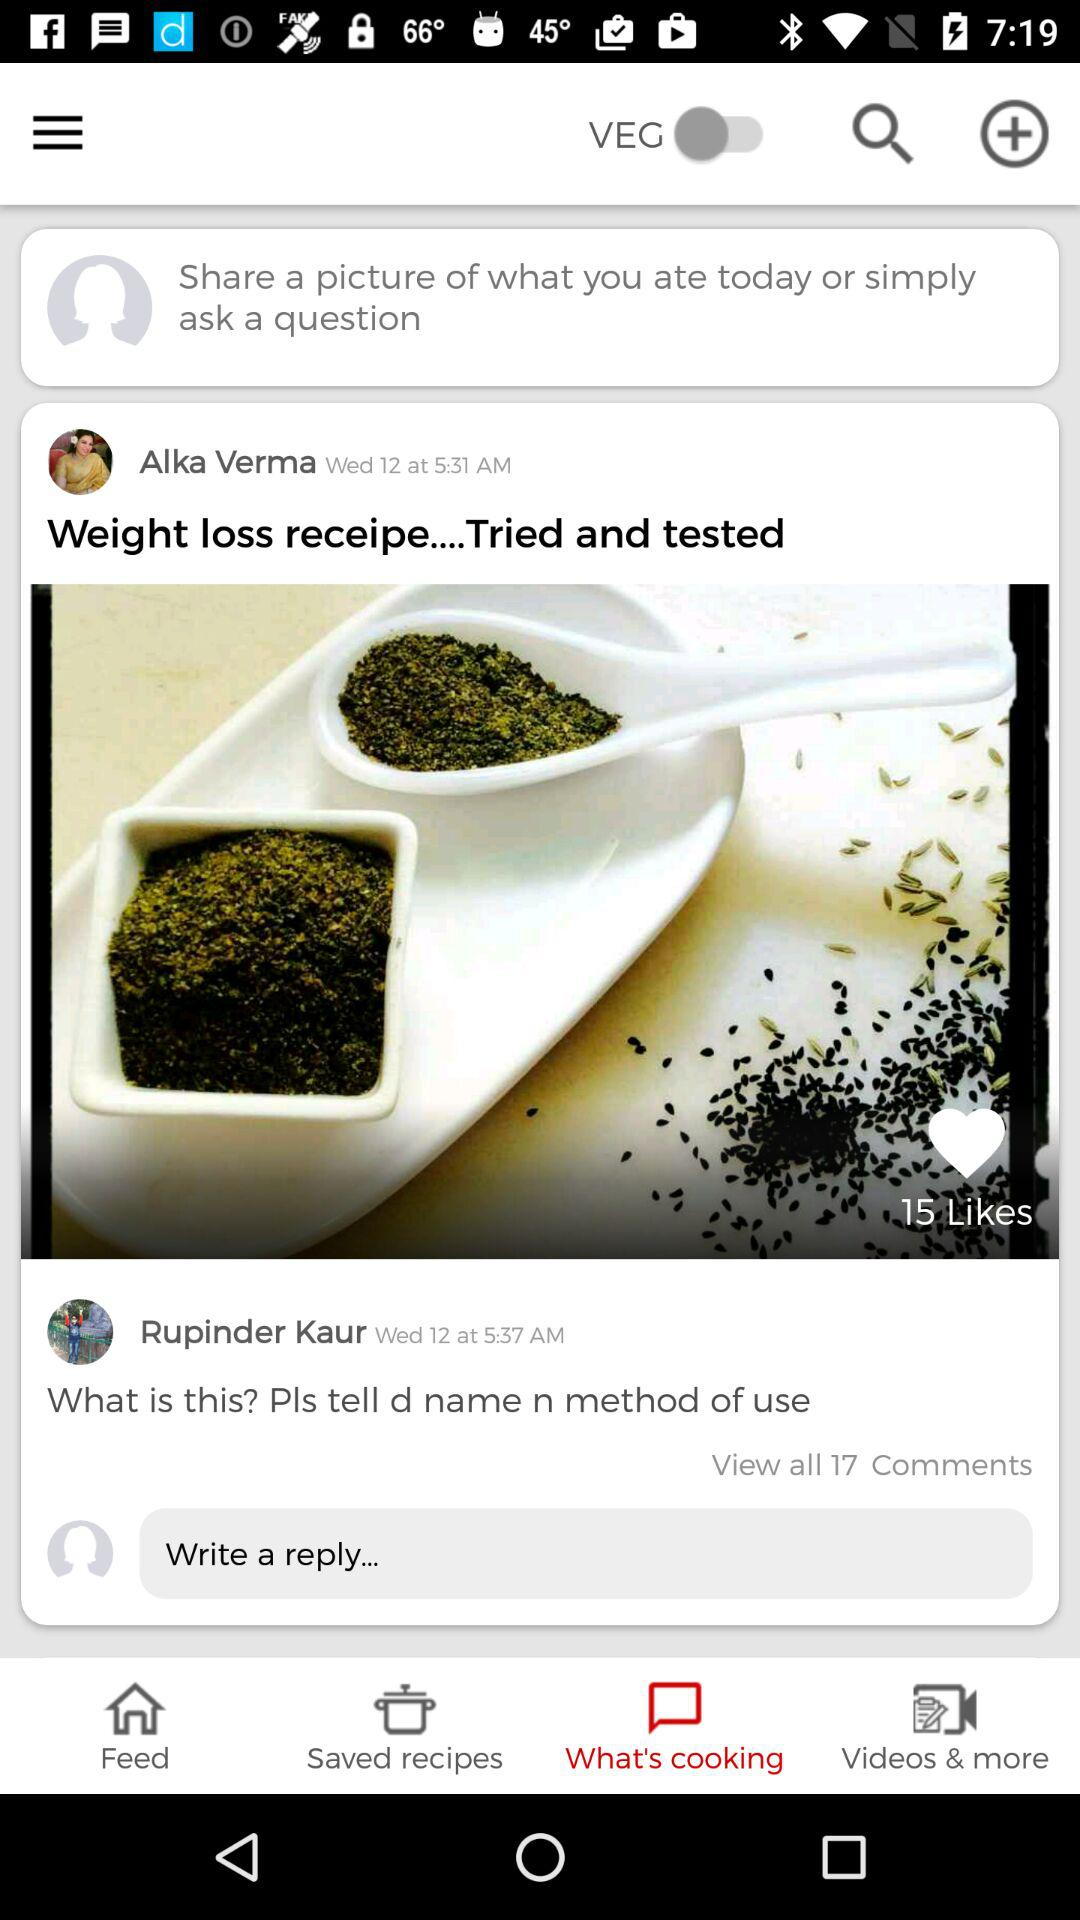How many people liked the post? There were 15 people who liked the post. 